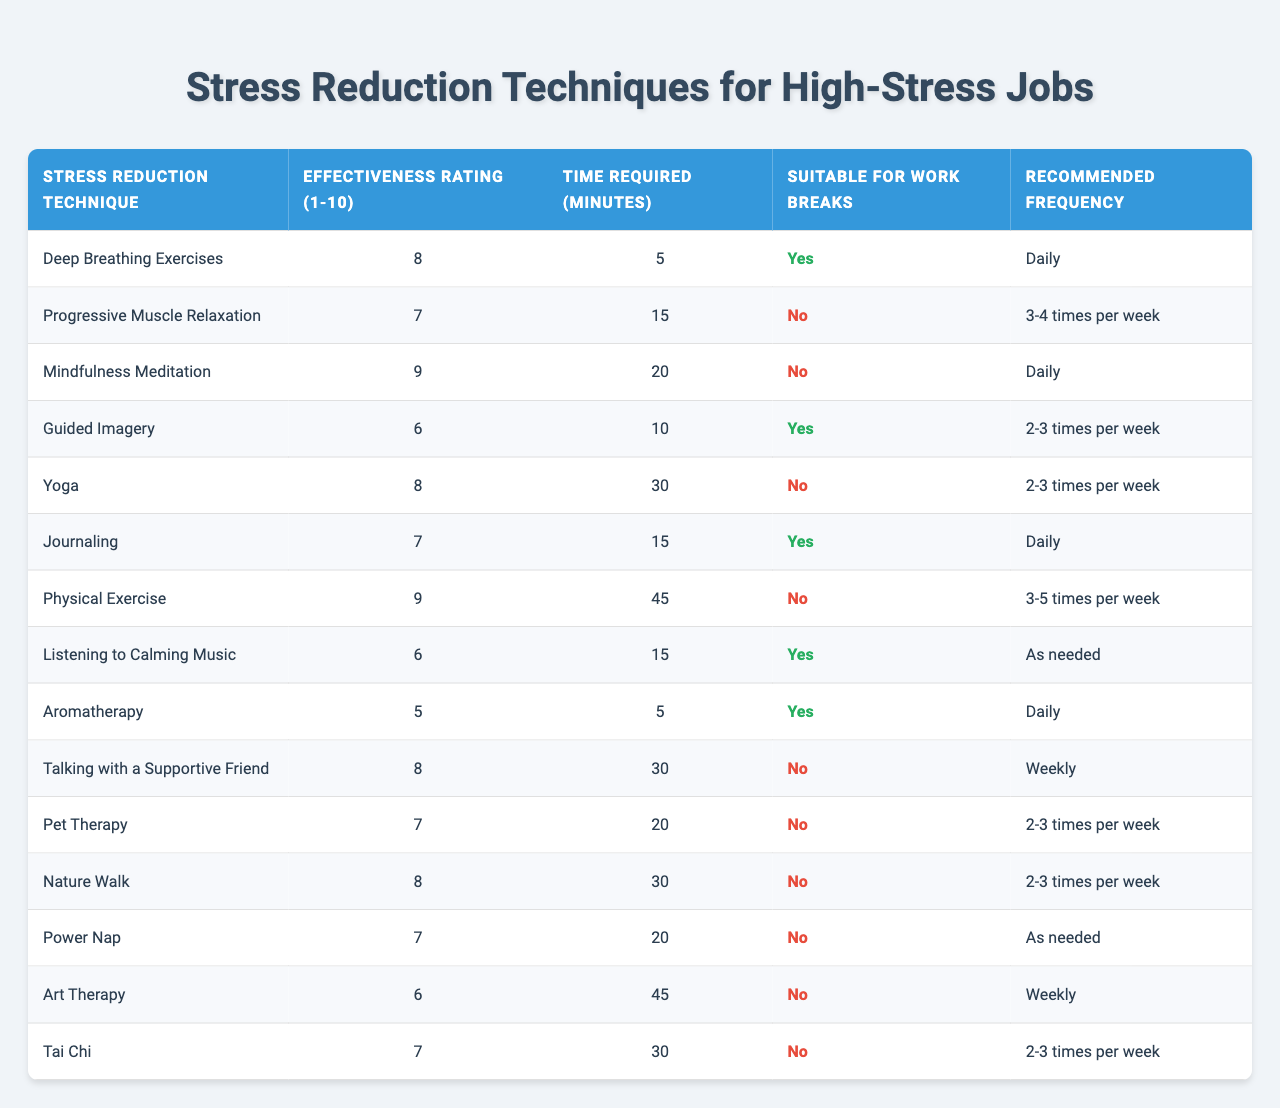What is the effectiveness rating for Deep Breathing Exercises? The table shows that Deep Breathing Exercises have an effectiveness rating of 8.
Answer: 8 Which technique has the highest effectiveness rating? The table indicates that Mindfulness Meditation and Physical Exercise both have the highest effectiveness ratings of 9.
Answer: Mindfulness Meditation and Physical Exercise How many minutes are needed for Progressive Muscle Relaxation? According to the table, Progressive Muscle Relaxation requires 15 minutes.
Answer: 15 minutes Is Guided Imagery suitable for work breaks? The table states that Guided Imagery is not suitable for work breaks (No).
Answer: No What is the recommended frequency for Journaling? The table shows that Journaling is recommended to be practiced daily.
Answer: Daily How many stress reduction techniques are suitable for work breaks? By reviewing the table, we can count the techniques marked "Yes" under Suitable for Work Breaks: Deep Breathing Exercises, Guided Imagery, Journaling, and Listening to Calming Music, totaling 4 techniques.
Answer: 4 What is the average effectiveness rating of all techniques listed? To calculate the average, we sum the effectiveness ratings: 8 + 7 + 9 + 6 + 8 + 7 + 9 + 6 + 5 + 8 + 7 + 8 + 7 + 6 + 7 = 115. There are 15 techniques, so the average is 115 / 15 = 7.67.
Answer: 7.67 Which technique requires the longest time to practice? Looking at the table, Physical Exercise requires the longest time at 45 minutes.
Answer: Physical Exercise Is there any technique that has both an effectiveness rating of 9 and is suitable for work breaks? By examining the table, we see that both techniques with an effectiveness rating of 9, Mindfulness Meditation and Physical Exercise, are not suitable for work breaks (No).
Answer: No What is the difference in effectiveness ratings between Yoga and Listening to Calming Music? Yoga has an effectiveness rating of 8, while Listening to Calming Music has a rating of 6. The difference is 8 - 6 = 2.
Answer: 2 